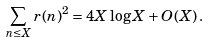Convert formula to latex. <formula><loc_0><loc_0><loc_500><loc_500>\sum _ { n \leq X } r ( n ) ^ { 2 } = 4 X \log X + O ( X ) \, .</formula> 